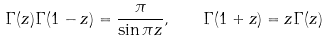Convert formula to latex. <formula><loc_0><loc_0><loc_500><loc_500>\Gamma ( z ) \Gamma ( 1 - z ) = \frac { \pi } { \sin \pi z } , \quad \Gamma ( 1 + z ) = z \Gamma ( z )</formula> 